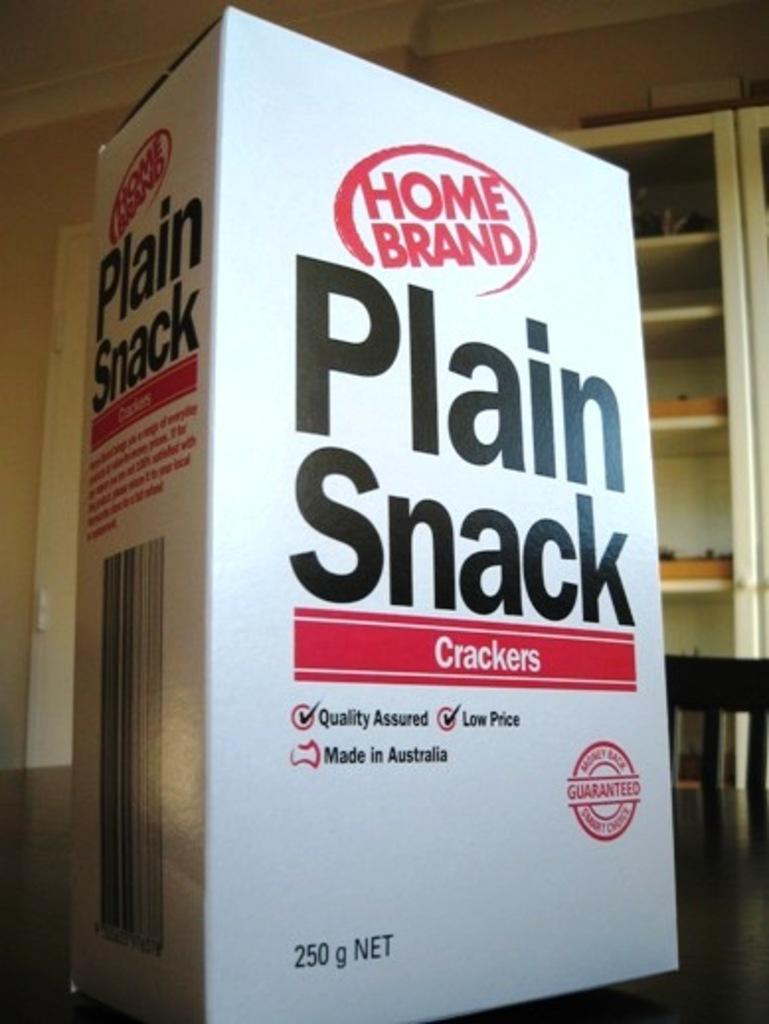What is in the box?
Provide a short and direct response. Crackers. What kind of crackers are these?
Keep it short and to the point. Plain snack. 